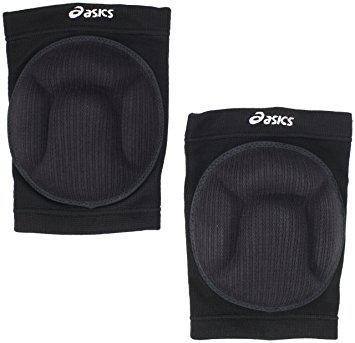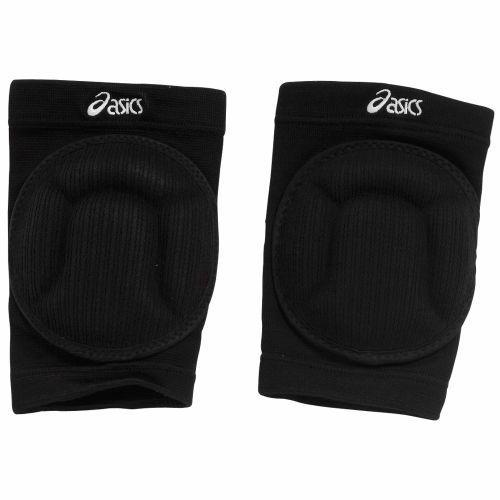The first image is the image on the left, the second image is the image on the right. For the images shown, is this caption "There are three or fewer black knee pads." true? Answer yes or no. No. The first image is the image on the left, the second image is the image on the right. Given the left and right images, does the statement "There is at least one white protective pad." hold true? Answer yes or no. No. 